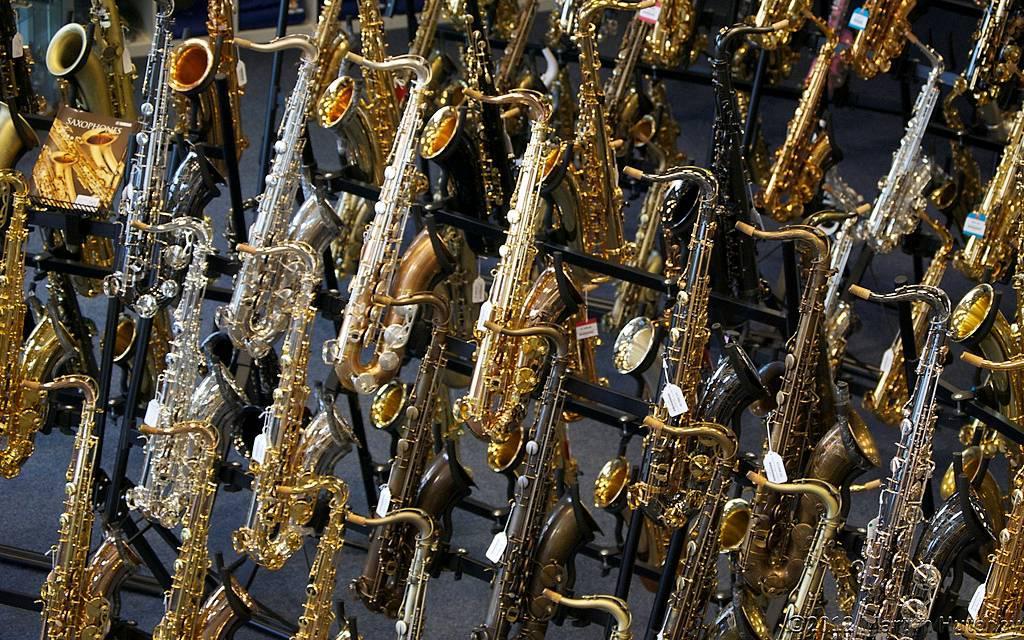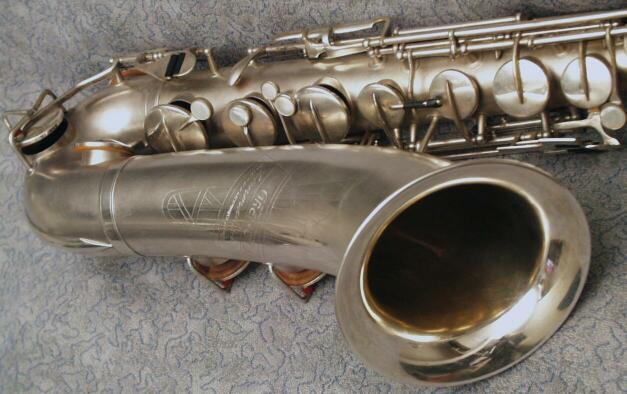The first image is the image on the left, the second image is the image on the right. For the images displayed, is the sentence "An image shows one saxophone with its mouthpiece separate on the display." factually correct? Answer yes or no. No. The first image is the image on the left, the second image is the image on the right. Examine the images to the left and right. Is the description "There are more instruments in the image on the right." accurate? Answer yes or no. No. 